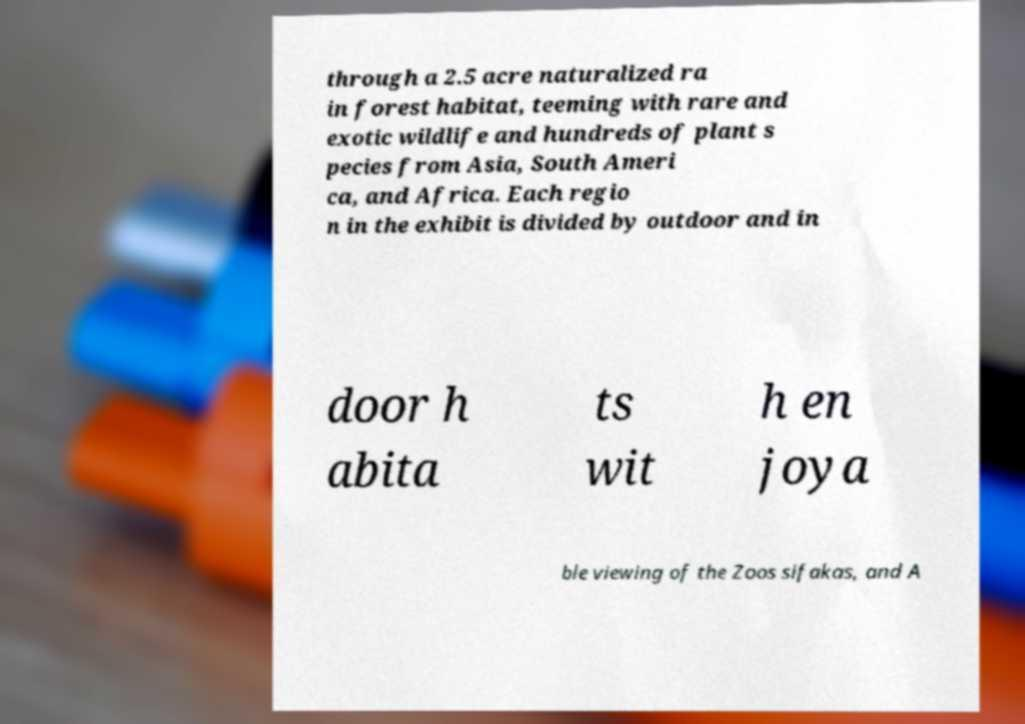Could you assist in decoding the text presented in this image and type it out clearly? through a 2.5 acre naturalized ra in forest habitat, teeming with rare and exotic wildlife and hundreds of plant s pecies from Asia, South Ameri ca, and Africa. Each regio n in the exhibit is divided by outdoor and in door h abita ts wit h en joya ble viewing of the Zoos sifakas, and A 